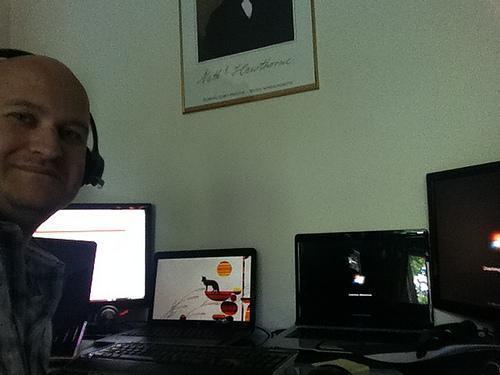How many pictures are on the wall?
Give a very brief answer. 1. How many people are there?
Give a very brief answer. 1. 